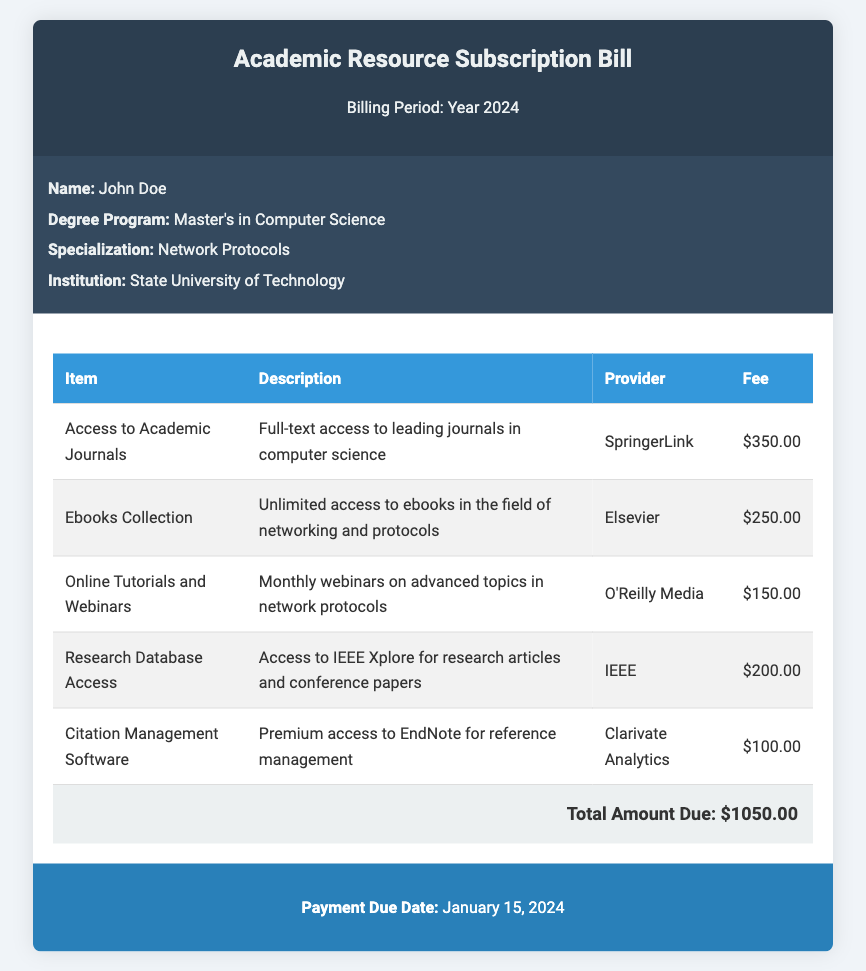what is the total amount due? The total amount due is stated clearly in the document as the sum of all fees listed in the table.
Answer: $1050.00 who is the subscriber? The document specifies the name of the subscriber at the top of the subscriber information section.
Answer: John Doe what is the payment due date? The payment due date is explicitly mentioned in the payment information section of the document.
Answer: January 15, 2024 how much is the fee for access to academic journals? The fee for access to academic journals is listed in the table under the respective item.
Answer: $350.00 which provider offers the ebooks collection? The provider for the ebooks collection is mentioned in the description of the respective item in the table.
Answer: Elsevier how many services are billed in total? The number of services listed can be counted from the rows present in the table.
Answer: 5 what type of subscription is this document about? The main theme of the document is evident from the title and the services listed within.
Answer: Academic Resource Subscription what is the fee for citation management software? The document states the fee associated with citation management software in the services table.
Answer: $100.00 what is the description for online tutorials and webinars? The description of online tutorials and webinars can be found directly in the table next to that item.
Answer: Monthly webinars on advanced topics in network protocols 